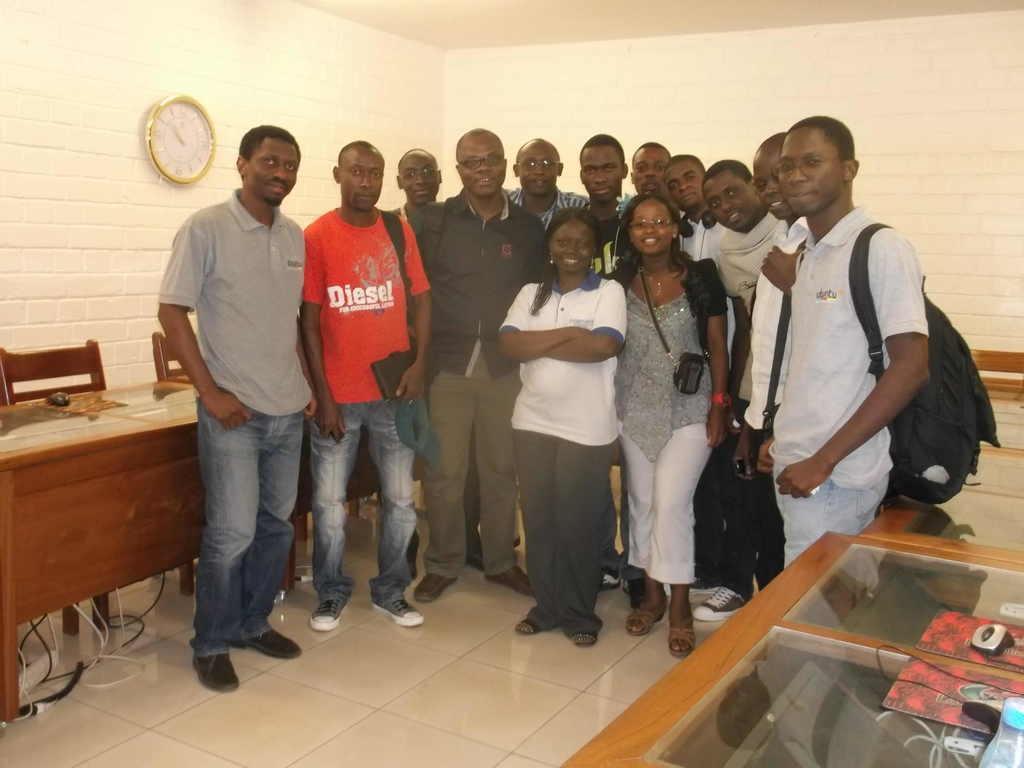Please provide a concise description of this image. The image is taken in a room. In the center of the image there are people standing, many are smiling. On the left there are cables, tables, chairs and a clock. On the right there are tables, books and other objects. The wall is painted white. 